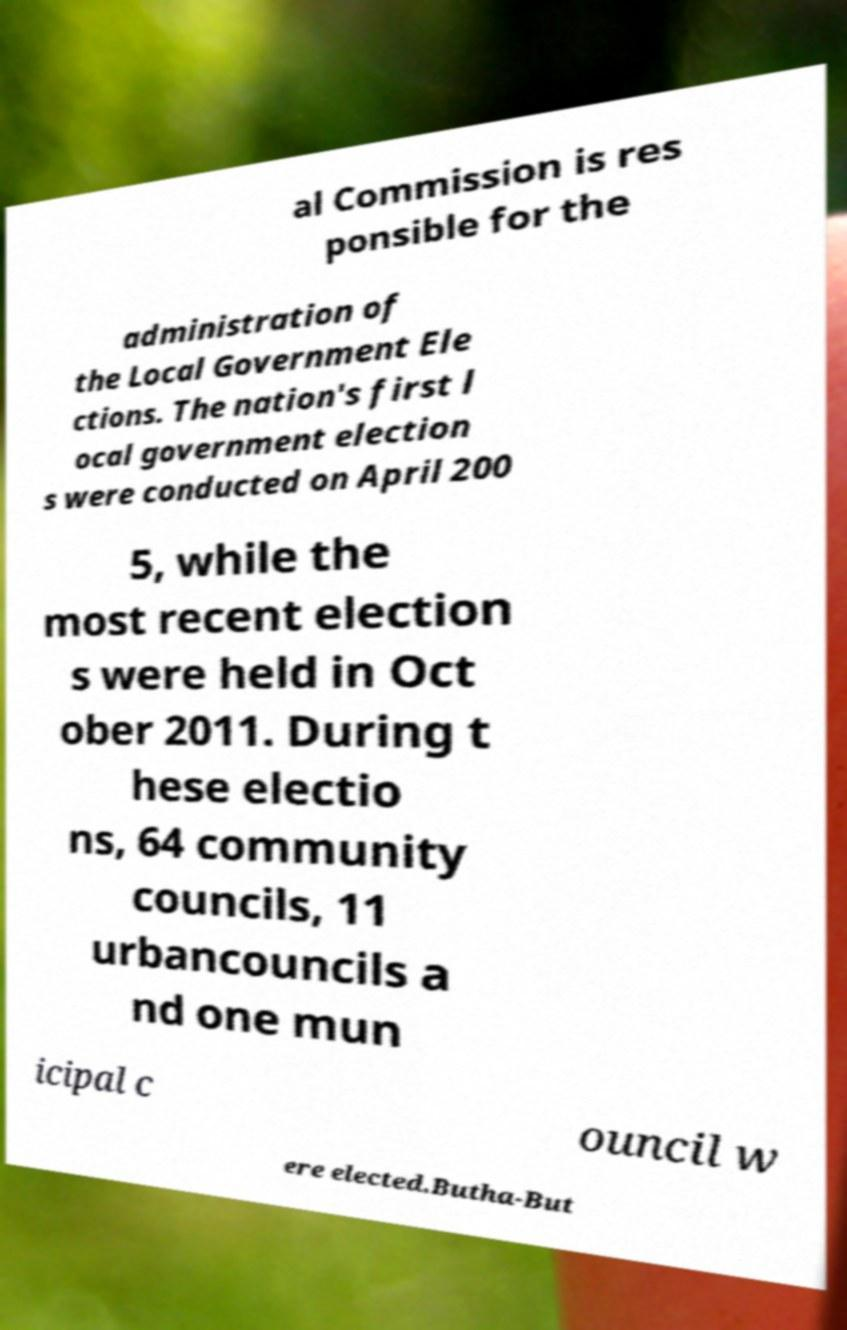For documentation purposes, I need the text within this image transcribed. Could you provide that? al Commission is res ponsible for the administration of the Local Government Ele ctions. The nation's first l ocal government election s were conducted on April 200 5, while the most recent election s were held in Oct ober 2011. During t hese electio ns, 64 community councils, 11 urbancouncils a nd one mun icipal c ouncil w ere elected.Butha-But 